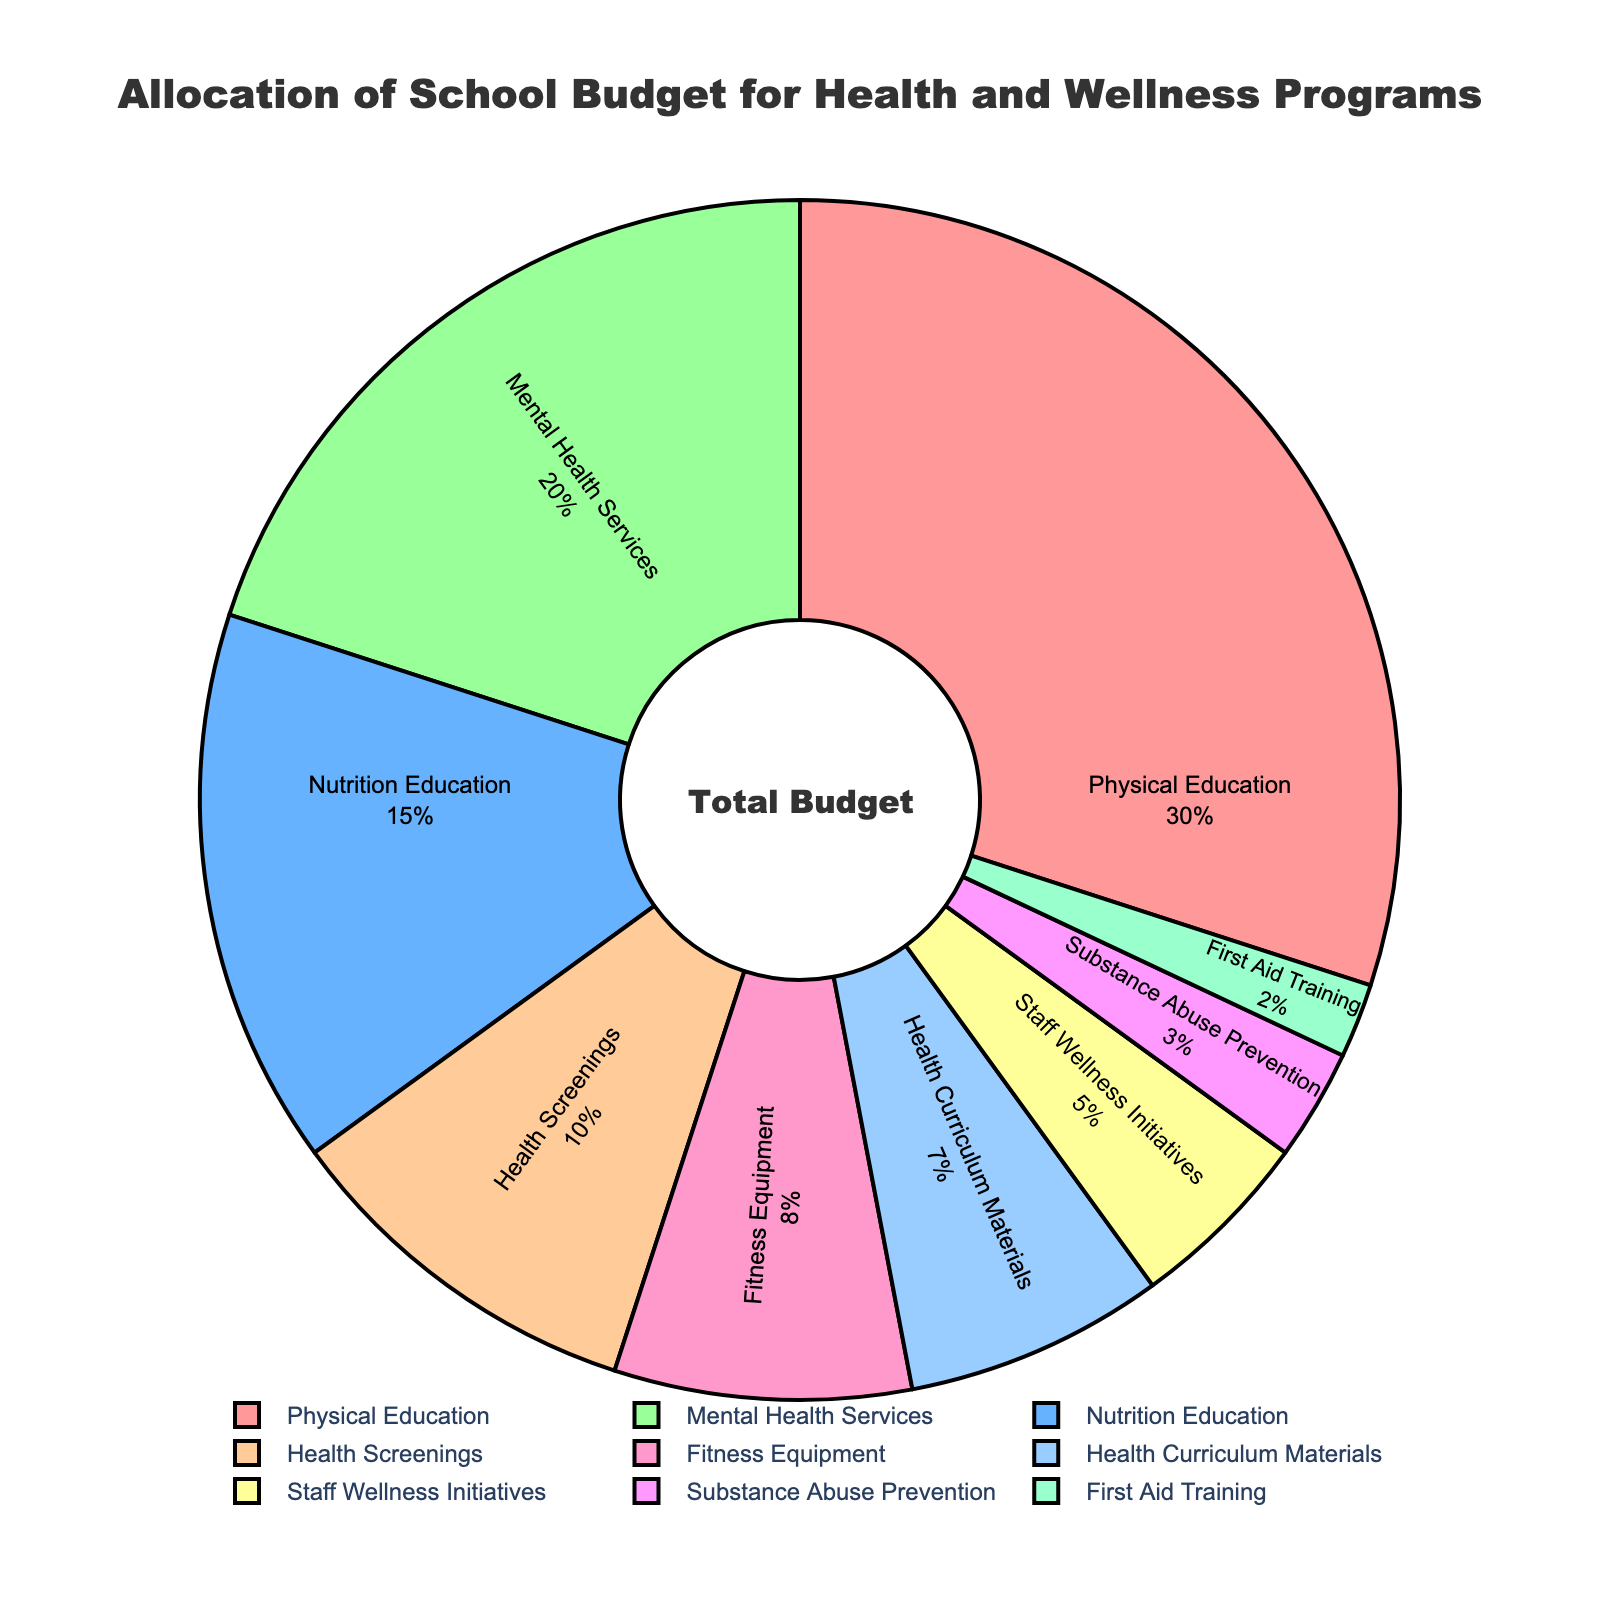Which program receives the largest portion of the budget? The largest portion corresponds to the segment of the pie chart with the largest area, which is labeled as "Physical Education."
Answer: Physical Education Which two programs, when combined, make up nearly half of the budget? Physical Education and Mental Health Services together make up 30% + 20%, which is 50% of the total budget.
Answer: Physical Education and Mental Health Services How much more is allocated to Physical Education compared to Nutrition Education? Physical Education is allocated 30%, and Nutrition Education is allocated 15%. The difference is 30% - 15% = 15%.
Answer: 15% Which program has the smallest allocation, and what percentage is it? The smallest segment of the pie chart corresponds to “First Aid Training” which is 2%.
Answer: First Aid Training, 2% Is the allocation for Health Screenings greater than the allocation for Staff Wellness Initiatives? Yes, the allocation for Health Screenings is 10%, whereas for Staff Wellness Initiatives it is 5%, thus 10% is greater than 5%.
Answer: Yes What percent of the budget is allocated to all programs except Physical Education and Mental Health Services? The allocation for all other programs combined can be computed as 100% - (30% + 20%) = 100% - 50% = 50%.
Answer: 50% If the budget for Fitness Equipment were increased by 2%, which two programs would then have the same budget allocation? Increasing the allocation for Fitness Equipment by 2% would give it a total of 10% (8% + 2%), matching the current budget for Health Screenings.
Answer: Fitness Equipment and Health Screenings Between Health Curriculum Materials and Fitness Equipment, which is allocated more budget and by how much? Fitness Equipment is allocated 8% while Health Curriculum Materials is allocated 7%, so the difference is 8% - 7% = 1%.
Answer: Fitness Equipment by 1% Comparing Nutrition Education and Mental Health Services, which has a higher allocation and what's the difference? Mental Health Services is allocated 20%, Nutrition Education is allocated 15%, thus Mental Health Services has 20% - 15% = 5% more.
Answer: Mental Health Services by 5% What is the total percentage allocated to programs related to staff (Staff Wellness Initiatives and First Aid Training)? The combined allocation for Staff Wellness Initiatives and First Aid Training is 5% + 2% = 7%.
Answer: 7% 